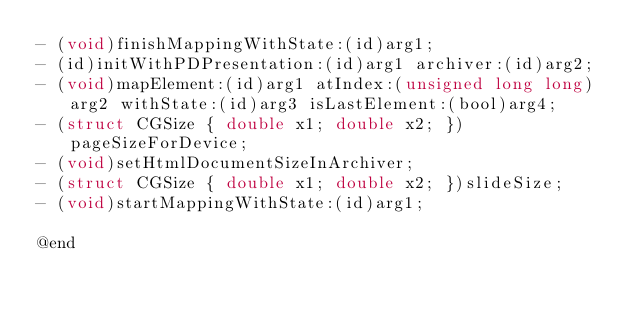<code> <loc_0><loc_0><loc_500><loc_500><_C_>- (void)finishMappingWithState:(id)arg1;
- (id)initWithPDPresentation:(id)arg1 archiver:(id)arg2;
- (void)mapElement:(id)arg1 atIndex:(unsigned long long)arg2 withState:(id)arg3 isLastElement:(bool)arg4;
- (struct CGSize { double x1; double x2; })pageSizeForDevice;
- (void)setHtmlDocumentSizeInArchiver;
- (struct CGSize { double x1; double x2; })slideSize;
- (void)startMappingWithState:(id)arg1;

@end
</code> 